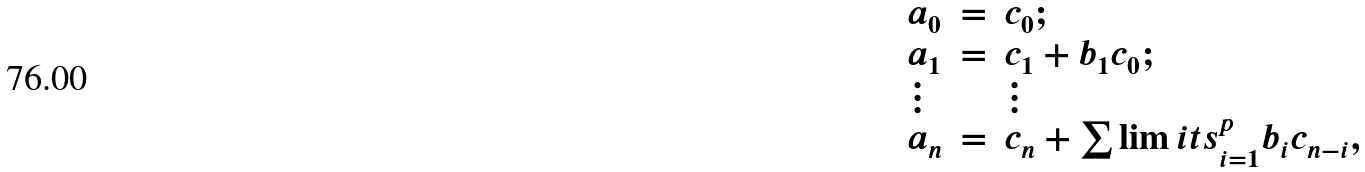Convert formula to latex. <formula><loc_0><loc_0><loc_500><loc_500>\begin{array} { l l l l l l l l l l } a _ { 0 } & = & c _ { 0 } ; \\ a _ { 1 } & = & c _ { 1 } + b _ { 1 } c _ { 0 } ; \\ \vdots & & \vdots \\ a _ { n } & = & c _ { n } + \sum \lim i t s _ { i = 1 } ^ { p } b _ { i } c _ { n - i } , \end{array}</formula> 